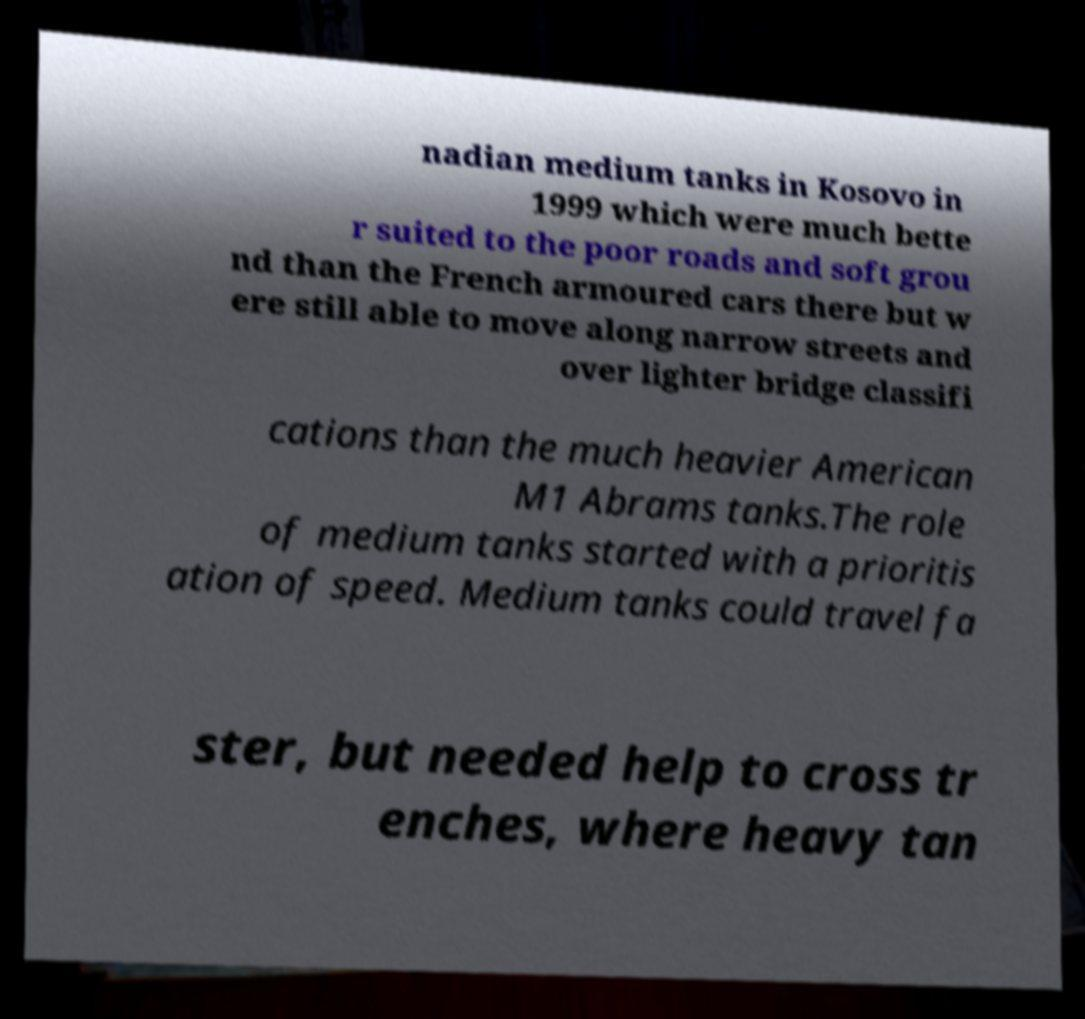Can you accurately transcribe the text from the provided image for me? nadian medium tanks in Kosovo in 1999 which were much bette r suited to the poor roads and soft grou nd than the French armoured cars there but w ere still able to move along narrow streets and over lighter bridge classifi cations than the much heavier American M1 Abrams tanks.The role of medium tanks started with a prioritis ation of speed. Medium tanks could travel fa ster, but needed help to cross tr enches, where heavy tan 